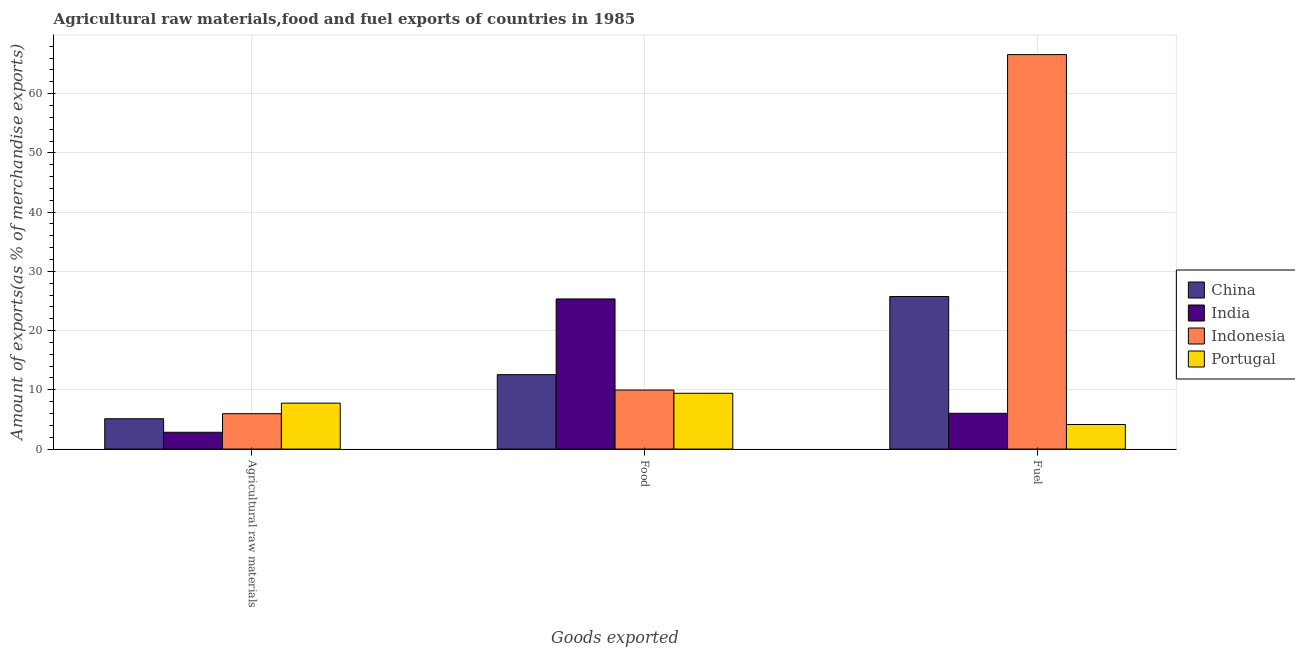How many different coloured bars are there?
Your answer should be very brief. 4. How many groups of bars are there?
Ensure brevity in your answer.  3. Are the number of bars per tick equal to the number of legend labels?
Your answer should be very brief. Yes. Are the number of bars on each tick of the X-axis equal?
Give a very brief answer. Yes. How many bars are there on the 3rd tick from the right?
Offer a very short reply. 4. What is the label of the 3rd group of bars from the left?
Provide a short and direct response. Fuel. What is the percentage of food exports in Indonesia?
Your answer should be very brief. 9.96. Across all countries, what is the maximum percentage of food exports?
Your answer should be very brief. 25.35. Across all countries, what is the minimum percentage of food exports?
Offer a terse response. 9.42. In which country was the percentage of fuel exports maximum?
Provide a succinct answer. Indonesia. In which country was the percentage of food exports minimum?
Your answer should be very brief. Portugal. What is the total percentage of fuel exports in the graph?
Provide a succinct answer. 102.54. What is the difference between the percentage of fuel exports in China and that in Indonesia?
Your answer should be very brief. -40.84. What is the difference between the percentage of raw materials exports in China and the percentage of food exports in Indonesia?
Make the answer very short. -4.84. What is the average percentage of raw materials exports per country?
Provide a succinct answer. 5.42. What is the difference between the percentage of raw materials exports and percentage of fuel exports in Indonesia?
Your answer should be very brief. -60.62. In how many countries, is the percentage of food exports greater than 40 %?
Provide a short and direct response. 0. What is the ratio of the percentage of raw materials exports in Portugal to that in India?
Your answer should be compact. 2.73. Is the percentage of fuel exports in China less than that in Portugal?
Your response must be concise. No. What is the difference between the highest and the second highest percentage of food exports?
Your answer should be very brief. 12.78. What is the difference between the highest and the lowest percentage of food exports?
Make the answer very short. 15.92. In how many countries, is the percentage of food exports greater than the average percentage of food exports taken over all countries?
Your answer should be compact. 1. What does the 4th bar from the left in Fuel represents?
Make the answer very short. Portugal. How many countries are there in the graph?
Offer a terse response. 4. What is the difference between two consecutive major ticks on the Y-axis?
Your response must be concise. 10. Does the graph contain any zero values?
Provide a succinct answer. No. How are the legend labels stacked?
Provide a short and direct response. Vertical. What is the title of the graph?
Offer a terse response. Agricultural raw materials,food and fuel exports of countries in 1985. What is the label or title of the X-axis?
Offer a terse response. Goods exported. What is the label or title of the Y-axis?
Provide a succinct answer. Amount of exports(as % of merchandise exports). What is the Amount of exports(as % of merchandise exports) of China in Agricultural raw materials?
Your answer should be compact. 5.12. What is the Amount of exports(as % of merchandise exports) in India in Agricultural raw materials?
Make the answer very short. 2.84. What is the Amount of exports(as % of merchandise exports) in Indonesia in Agricultural raw materials?
Offer a very short reply. 5.98. What is the Amount of exports(as % of merchandise exports) of Portugal in Agricultural raw materials?
Ensure brevity in your answer.  7.76. What is the Amount of exports(as % of merchandise exports) in China in Food?
Ensure brevity in your answer.  12.57. What is the Amount of exports(as % of merchandise exports) of India in Food?
Make the answer very short. 25.35. What is the Amount of exports(as % of merchandise exports) of Indonesia in Food?
Your response must be concise. 9.96. What is the Amount of exports(as % of merchandise exports) in Portugal in Food?
Offer a very short reply. 9.42. What is the Amount of exports(as % of merchandise exports) in China in Fuel?
Ensure brevity in your answer.  25.76. What is the Amount of exports(as % of merchandise exports) in India in Fuel?
Make the answer very short. 6.04. What is the Amount of exports(as % of merchandise exports) in Indonesia in Fuel?
Make the answer very short. 66.6. What is the Amount of exports(as % of merchandise exports) of Portugal in Fuel?
Keep it short and to the point. 4.15. Across all Goods exported, what is the maximum Amount of exports(as % of merchandise exports) of China?
Ensure brevity in your answer.  25.76. Across all Goods exported, what is the maximum Amount of exports(as % of merchandise exports) in India?
Your response must be concise. 25.35. Across all Goods exported, what is the maximum Amount of exports(as % of merchandise exports) in Indonesia?
Provide a short and direct response. 66.6. Across all Goods exported, what is the maximum Amount of exports(as % of merchandise exports) in Portugal?
Your answer should be compact. 9.42. Across all Goods exported, what is the minimum Amount of exports(as % of merchandise exports) of China?
Provide a succinct answer. 5.12. Across all Goods exported, what is the minimum Amount of exports(as % of merchandise exports) of India?
Offer a very short reply. 2.84. Across all Goods exported, what is the minimum Amount of exports(as % of merchandise exports) of Indonesia?
Give a very brief answer. 5.98. Across all Goods exported, what is the minimum Amount of exports(as % of merchandise exports) of Portugal?
Your answer should be compact. 4.15. What is the total Amount of exports(as % of merchandise exports) in China in the graph?
Offer a very short reply. 43.45. What is the total Amount of exports(as % of merchandise exports) of India in the graph?
Your answer should be very brief. 34.22. What is the total Amount of exports(as % of merchandise exports) of Indonesia in the graph?
Offer a very short reply. 82.54. What is the total Amount of exports(as % of merchandise exports) of Portugal in the graph?
Give a very brief answer. 21.32. What is the difference between the Amount of exports(as % of merchandise exports) of China in Agricultural raw materials and that in Food?
Provide a short and direct response. -7.44. What is the difference between the Amount of exports(as % of merchandise exports) of India in Agricultural raw materials and that in Food?
Make the answer very short. -22.51. What is the difference between the Amount of exports(as % of merchandise exports) of Indonesia in Agricultural raw materials and that in Food?
Ensure brevity in your answer.  -3.99. What is the difference between the Amount of exports(as % of merchandise exports) in Portugal in Agricultural raw materials and that in Food?
Provide a succinct answer. -1.67. What is the difference between the Amount of exports(as % of merchandise exports) in China in Agricultural raw materials and that in Fuel?
Provide a succinct answer. -20.64. What is the difference between the Amount of exports(as % of merchandise exports) of India in Agricultural raw materials and that in Fuel?
Keep it short and to the point. -3.2. What is the difference between the Amount of exports(as % of merchandise exports) of Indonesia in Agricultural raw materials and that in Fuel?
Keep it short and to the point. -60.62. What is the difference between the Amount of exports(as % of merchandise exports) of Portugal in Agricultural raw materials and that in Fuel?
Provide a succinct answer. 3.61. What is the difference between the Amount of exports(as % of merchandise exports) of China in Food and that in Fuel?
Provide a succinct answer. -13.19. What is the difference between the Amount of exports(as % of merchandise exports) of India in Food and that in Fuel?
Provide a short and direct response. 19.31. What is the difference between the Amount of exports(as % of merchandise exports) of Indonesia in Food and that in Fuel?
Your answer should be compact. -56.63. What is the difference between the Amount of exports(as % of merchandise exports) of Portugal in Food and that in Fuel?
Provide a succinct answer. 5.28. What is the difference between the Amount of exports(as % of merchandise exports) in China in Agricultural raw materials and the Amount of exports(as % of merchandise exports) in India in Food?
Your answer should be compact. -20.22. What is the difference between the Amount of exports(as % of merchandise exports) in China in Agricultural raw materials and the Amount of exports(as % of merchandise exports) in Indonesia in Food?
Provide a short and direct response. -4.84. What is the difference between the Amount of exports(as % of merchandise exports) of China in Agricultural raw materials and the Amount of exports(as % of merchandise exports) of Portugal in Food?
Give a very brief answer. -4.3. What is the difference between the Amount of exports(as % of merchandise exports) of India in Agricultural raw materials and the Amount of exports(as % of merchandise exports) of Indonesia in Food?
Your answer should be compact. -7.13. What is the difference between the Amount of exports(as % of merchandise exports) in India in Agricultural raw materials and the Amount of exports(as % of merchandise exports) in Portugal in Food?
Provide a succinct answer. -6.58. What is the difference between the Amount of exports(as % of merchandise exports) of Indonesia in Agricultural raw materials and the Amount of exports(as % of merchandise exports) of Portugal in Food?
Keep it short and to the point. -3.44. What is the difference between the Amount of exports(as % of merchandise exports) of China in Agricultural raw materials and the Amount of exports(as % of merchandise exports) of India in Fuel?
Ensure brevity in your answer.  -0.92. What is the difference between the Amount of exports(as % of merchandise exports) of China in Agricultural raw materials and the Amount of exports(as % of merchandise exports) of Indonesia in Fuel?
Keep it short and to the point. -61.48. What is the difference between the Amount of exports(as % of merchandise exports) of China in Agricultural raw materials and the Amount of exports(as % of merchandise exports) of Portugal in Fuel?
Your answer should be very brief. 0.98. What is the difference between the Amount of exports(as % of merchandise exports) of India in Agricultural raw materials and the Amount of exports(as % of merchandise exports) of Indonesia in Fuel?
Provide a succinct answer. -63.76. What is the difference between the Amount of exports(as % of merchandise exports) of India in Agricultural raw materials and the Amount of exports(as % of merchandise exports) of Portugal in Fuel?
Give a very brief answer. -1.31. What is the difference between the Amount of exports(as % of merchandise exports) in Indonesia in Agricultural raw materials and the Amount of exports(as % of merchandise exports) in Portugal in Fuel?
Keep it short and to the point. 1.83. What is the difference between the Amount of exports(as % of merchandise exports) of China in Food and the Amount of exports(as % of merchandise exports) of India in Fuel?
Your response must be concise. 6.53. What is the difference between the Amount of exports(as % of merchandise exports) of China in Food and the Amount of exports(as % of merchandise exports) of Indonesia in Fuel?
Make the answer very short. -54.03. What is the difference between the Amount of exports(as % of merchandise exports) of China in Food and the Amount of exports(as % of merchandise exports) of Portugal in Fuel?
Offer a terse response. 8.42. What is the difference between the Amount of exports(as % of merchandise exports) of India in Food and the Amount of exports(as % of merchandise exports) of Indonesia in Fuel?
Your answer should be very brief. -41.25. What is the difference between the Amount of exports(as % of merchandise exports) of India in Food and the Amount of exports(as % of merchandise exports) of Portugal in Fuel?
Your answer should be compact. 21.2. What is the difference between the Amount of exports(as % of merchandise exports) in Indonesia in Food and the Amount of exports(as % of merchandise exports) in Portugal in Fuel?
Ensure brevity in your answer.  5.82. What is the average Amount of exports(as % of merchandise exports) of China per Goods exported?
Provide a short and direct response. 14.48. What is the average Amount of exports(as % of merchandise exports) in India per Goods exported?
Keep it short and to the point. 11.41. What is the average Amount of exports(as % of merchandise exports) in Indonesia per Goods exported?
Keep it short and to the point. 27.51. What is the average Amount of exports(as % of merchandise exports) of Portugal per Goods exported?
Provide a succinct answer. 7.11. What is the difference between the Amount of exports(as % of merchandise exports) of China and Amount of exports(as % of merchandise exports) of India in Agricultural raw materials?
Offer a very short reply. 2.28. What is the difference between the Amount of exports(as % of merchandise exports) in China and Amount of exports(as % of merchandise exports) in Indonesia in Agricultural raw materials?
Provide a succinct answer. -0.86. What is the difference between the Amount of exports(as % of merchandise exports) of China and Amount of exports(as % of merchandise exports) of Portugal in Agricultural raw materials?
Your answer should be very brief. -2.63. What is the difference between the Amount of exports(as % of merchandise exports) of India and Amount of exports(as % of merchandise exports) of Indonesia in Agricultural raw materials?
Ensure brevity in your answer.  -3.14. What is the difference between the Amount of exports(as % of merchandise exports) of India and Amount of exports(as % of merchandise exports) of Portugal in Agricultural raw materials?
Provide a succinct answer. -4.92. What is the difference between the Amount of exports(as % of merchandise exports) in Indonesia and Amount of exports(as % of merchandise exports) in Portugal in Agricultural raw materials?
Provide a short and direct response. -1.78. What is the difference between the Amount of exports(as % of merchandise exports) of China and Amount of exports(as % of merchandise exports) of India in Food?
Your response must be concise. -12.78. What is the difference between the Amount of exports(as % of merchandise exports) in China and Amount of exports(as % of merchandise exports) in Indonesia in Food?
Give a very brief answer. 2.6. What is the difference between the Amount of exports(as % of merchandise exports) of China and Amount of exports(as % of merchandise exports) of Portugal in Food?
Offer a very short reply. 3.15. What is the difference between the Amount of exports(as % of merchandise exports) in India and Amount of exports(as % of merchandise exports) in Indonesia in Food?
Provide a short and direct response. 15.38. What is the difference between the Amount of exports(as % of merchandise exports) in India and Amount of exports(as % of merchandise exports) in Portugal in Food?
Provide a short and direct response. 15.92. What is the difference between the Amount of exports(as % of merchandise exports) of Indonesia and Amount of exports(as % of merchandise exports) of Portugal in Food?
Provide a short and direct response. 0.54. What is the difference between the Amount of exports(as % of merchandise exports) in China and Amount of exports(as % of merchandise exports) in India in Fuel?
Your response must be concise. 19.72. What is the difference between the Amount of exports(as % of merchandise exports) in China and Amount of exports(as % of merchandise exports) in Indonesia in Fuel?
Offer a terse response. -40.84. What is the difference between the Amount of exports(as % of merchandise exports) of China and Amount of exports(as % of merchandise exports) of Portugal in Fuel?
Your response must be concise. 21.61. What is the difference between the Amount of exports(as % of merchandise exports) of India and Amount of exports(as % of merchandise exports) of Indonesia in Fuel?
Give a very brief answer. -60.56. What is the difference between the Amount of exports(as % of merchandise exports) in India and Amount of exports(as % of merchandise exports) in Portugal in Fuel?
Your answer should be very brief. 1.89. What is the difference between the Amount of exports(as % of merchandise exports) in Indonesia and Amount of exports(as % of merchandise exports) in Portugal in Fuel?
Provide a succinct answer. 62.45. What is the ratio of the Amount of exports(as % of merchandise exports) of China in Agricultural raw materials to that in Food?
Provide a succinct answer. 0.41. What is the ratio of the Amount of exports(as % of merchandise exports) of India in Agricultural raw materials to that in Food?
Offer a very short reply. 0.11. What is the ratio of the Amount of exports(as % of merchandise exports) in Indonesia in Agricultural raw materials to that in Food?
Your answer should be compact. 0.6. What is the ratio of the Amount of exports(as % of merchandise exports) in Portugal in Agricultural raw materials to that in Food?
Your answer should be very brief. 0.82. What is the ratio of the Amount of exports(as % of merchandise exports) in China in Agricultural raw materials to that in Fuel?
Keep it short and to the point. 0.2. What is the ratio of the Amount of exports(as % of merchandise exports) of India in Agricultural raw materials to that in Fuel?
Your answer should be very brief. 0.47. What is the ratio of the Amount of exports(as % of merchandise exports) of Indonesia in Agricultural raw materials to that in Fuel?
Your answer should be compact. 0.09. What is the ratio of the Amount of exports(as % of merchandise exports) of Portugal in Agricultural raw materials to that in Fuel?
Your answer should be very brief. 1.87. What is the ratio of the Amount of exports(as % of merchandise exports) of China in Food to that in Fuel?
Keep it short and to the point. 0.49. What is the ratio of the Amount of exports(as % of merchandise exports) in India in Food to that in Fuel?
Keep it short and to the point. 4.2. What is the ratio of the Amount of exports(as % of merchandise exports) of Indonesia in Food to that in Fuel?
Offer a terse response. 0.15. What is the ratio of the Amount of exports(as % of merchandise exports) in Portugal in Food to that in Fuel?
Your answer should be compact. 2.27. What is the difference between the highest and the second highest Amount of exports(as % of merchandise exports) in China?
Your answer should be very brief. 13.19. What is the difference between the highest and the second highest Amount of exports(as % of merchandise exports) in India?
Offer a very short reply. 19.31. What is the difference between the highest and the second highest Amount of exports(as % of merchandise exports) of Indonesia?
Keep it short and to the point. 56.63. What is the difference between the highest and the second highest Amount of exports(as % of merchandise exports) of Portugal?
Offer a very short reply. 1.67. What is the difference between the highest and the lowest Amount of exports(as % of merchandise exports) of China?
Make the answer very short. 20.64. What is the difference between the highest and the lowest Amount of exports(as % of merchandise exports) of India?
Offer a terse response. 22.51. What is the difference between the highest and the lowest Amount of exports(as % of merchandise exports) of Indonesia?
Your answer should be compact. 60.62. What is the difference between the highest and the lowest Amount of exports(as % of merchandise exports) in Portugal?
Your answer should be very brief. 5.28. 